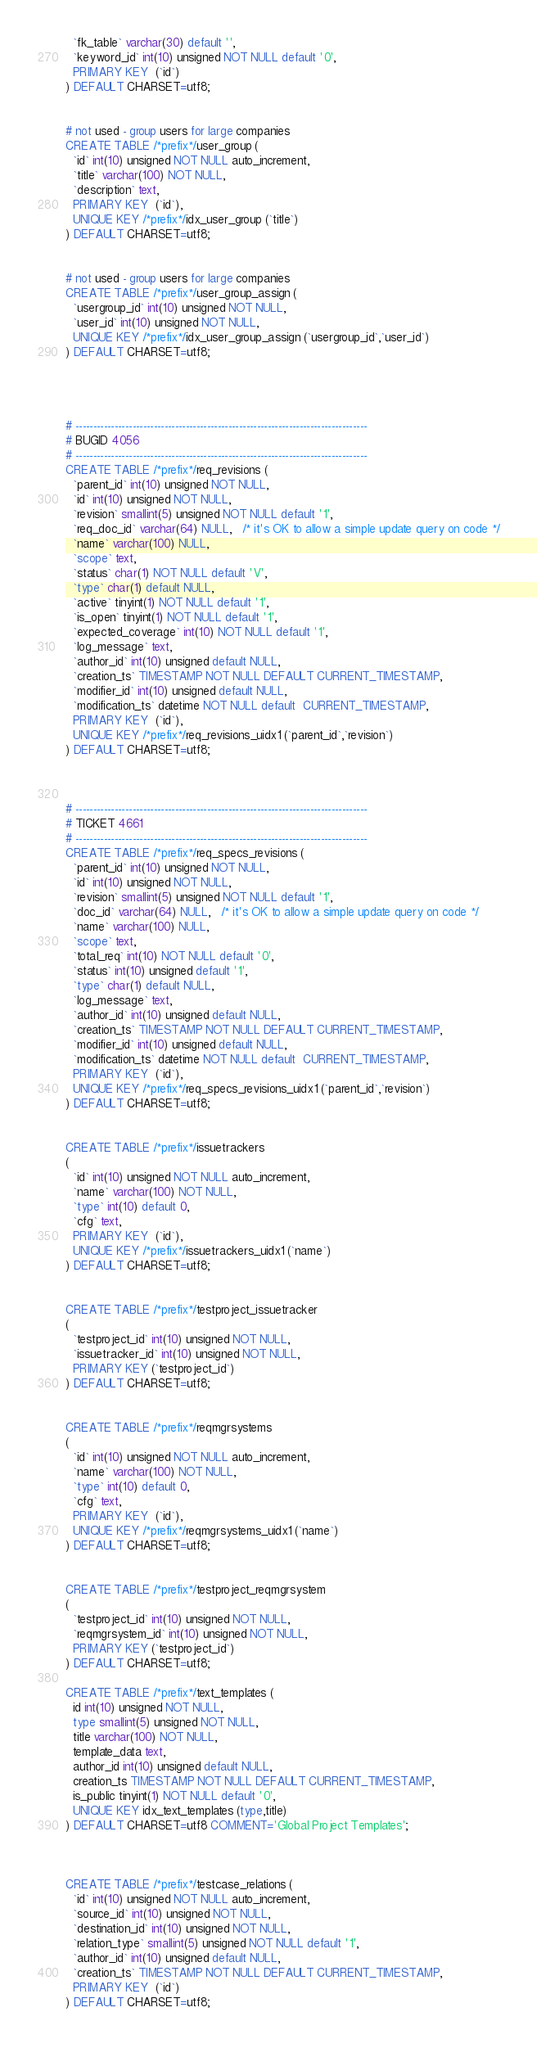<code> <loc_0><loc_0><loc_500><loc_500><_SQL_>  `fk_table` varchar(30) default '',
  `keyword_id` int(10) unsigned NOT NULL default '0',
  PRIMARY KEY  (`id`)
) DEFAULT CHARSET=utf8; 


# not used - group users for large companies 
CREATE TABLE /*prefix*/user_group (
  `id` int(10) unsigned NOT NULL auto_increment,
  `title` varchar(100) NOT NULL,
  `description` text,
  PRIMARY KEY  (`id`),
  UNIQUE KEY /*prefix*/idx_user_group (`title`)
) DEFAULT CHARSET=utf8;


# not used - group users for large companies 
CREATE TABLE /*prefix*/user_group_assign (
  `usergroup_id` int(10) unsigned NOT NULL,
  `user_id` int(10) unsigned NOT NULL,
  UNIQUE KEY /*prefix*/idx_user_group_assign (`usergroup_id`,`user_id`)
) DEFAULT CHARSET=utf8;




# ----------------------------------------------------------------------------------
# BUGID 4056
# ----------------------------------------------------------------------------------
CREATE TABLE /*prefix*/req_revisions (
  `parent_id` int(10) unsigned NOT NULL,
  `id` int(10) unsigned NOT NULL,
  `revision` smallint(5) unsigned NOT NULL default '1',
  `req_doc_id` varchar(64) NULL,   /* it's OK to allow a simple update query on code */
  `name` varchar(100) NULL,
  `scope` text,
  `status` char(1) NOT NULL default 'V',
  `type` char(1) default NULL,
  `active` tinyint(1) NOT NULL default '1',
  `is_open` tinyint(1) NOT NULL default '1',
  `expected_coverage` int(10) NOT NULL default '1',
  `log_message` text,
  `author_id` int(10) unsigned default NULL,
  `creation_ts` TIMESTAMP NOT NULL DEFAULT CURRENT_TIMESTAMP,
  `modifier_id` int(10) unsigned default NULL,
  `modification_ts` datetime NOT NULL default  CURRENT_TIMESTAMP,
  PRIMARY KEY  (`id`),
  UNIQUE KEY /*prefix*/req_revisions_uidx1 (`parent_id`,`revision`)
) DEFAULT CHARSET=utf8;



# ----------------------------------------------------------------------------------
# TICKET 4661
# ----------------------------------------------------------------------------------
CREATE TABLE /*prefix*/req_specs_revisions (
  `parent_id` int(10) unsigned NOT NULL,
  `id` int(10) unsigned NOT NULL,
  `revision` smallint(5) unsigned NOT NULL default '1',
  `doc_id` varchar(64) NULL,   /* it's OK to allow a simple update query on code */
  `name` varchar(100) NULL,
  `scope` text,
  `total_req` int(10) NOT NULL default '0',  
  `status` int(10) unsigned default '1',
  `type` char(1) default NULL,
  `log_message` text,
  `author_id` int(10) unsigned default NULL,
  `creation_ts` TIMESTAMP NOT NULL DEFAULT CURRENT_TIMESTAMP,
  `modifier_id` int(10) unsigned default NULL,
  `modification_ts` datetime NOT NULL default  CURRENT_TIMESTAMP,
  PRIMARY KEY  (`id`),
  UNIQUE KEY /*prefix*/req_specs_revisions_uidx1 (`parent_id`,`revision`)
) DEFAULT CHARSET=utf8;


CREATE TABLE /*prefix*/issuetrackers
(
  `id` int(10) unsigned NOT NULL auto_increment,
  `name` varchar(100) NOT NULL,
  `type` int(10) default 0,
  `cfg` text,
  PRIMARY KEY  (`id`),
  UNIQUE KEY /*prefix*/issuetrackers_uidx1 (`name`)
) DEFAULT CHARSET=utf8;


CREATE TABLE /*prefix*/testproject_issuetracker
(
  `testproject_id` int(10) unsigned NOT NULL,
  `issuetracker_id` int(10) unsigned NOT NULL,
  PRIMARY KEY (`testproject_id`)
) DEFAULT CHARSET=utf8;


CREATE TABLE /*prefix*/reqmgrsystems
(
  `id` int(10) unsigned NOT NULL auto_increment,
  `name` varchar(100) NOT NULL,
  `type` int(10) default 0,
  `cfg` text,
  PRIMARY KEY  (`id`),
  UNIQUE KEY /*prefix*/reqmgrsystems_uidx1 (`name`)
) DEFAULT CHARSET=utf8;


CREATE TABLE /*prefix*/testproject_reqmgrsystem
(
  `testproject_id` int(10) unsigned NOT NULL,
  `reqmgrsystem_id` int(10) unsigned NOT NULL,
  PRIMARY KEY (`testproject_id`)
) DEFAULT CHARSET=utf8;

CREATE TABLE /*prefix*/text_templates (
  id int(10) unsigned NOT NULL,
  type smallint(5) unsigned NOT NULL,
  title varchar(100) NOT NULL,
  template_data text,
  author_id int(10) unsigned default NULL,
  creation_ts TIMESTAMP NOT NULL DEFAULT CURRENT_TIMESTAMP,
  is_public tinyint(1) NOT NULL default '0',
  UNIQUE KEY idx_text_templates (type,title)
) DEFAULT CHARSET=utf8 COMMENT='Global Project Templates';



CREATE TABLE /*prefix*/testcase_relations (
  `id` int(10) unsigned NOT NULL auto_increment,
  `source_id` int(10) unsigned NOT NULL,
  `destination_id` int(10) unsigned NOT NULL,
  `relation_type` smallint(5) unsigned NOT NULL default '1',
  `author_id` int(10) unsigned default NULL,
  `creation_ts` TIMESTAMP NOT NULL DEFAULT CURRENT_TIMESTAMP,
  PRIMARY KEY  (`id`)
) DEFAULT CHARSET=utf8;
</code> 